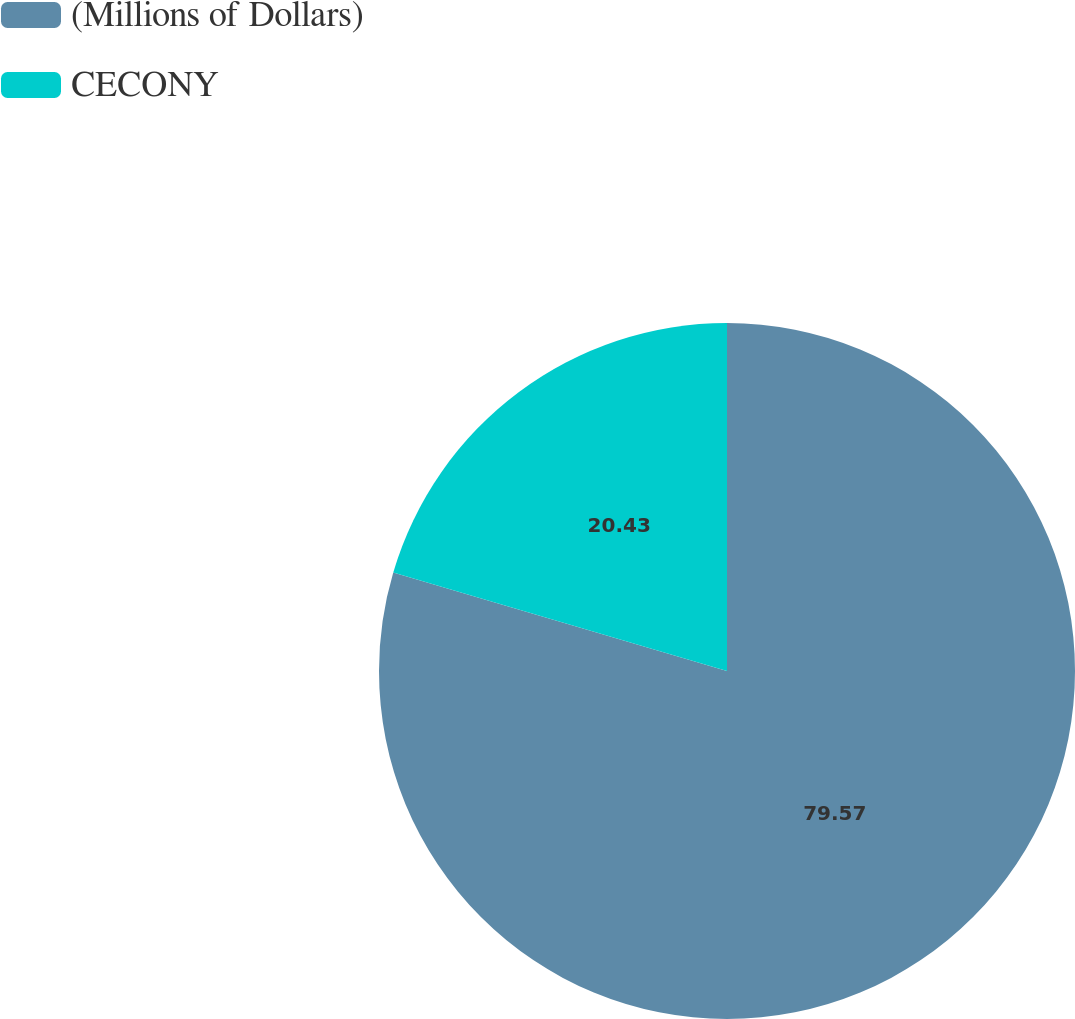Convert chart. <chart><loc_0><loc_0><loc_500><loc_500><pie_chart><fcel>(Millions of Dollars)<fcel>CECONY<nl><fcel>79.57%<fcel>20.43%<nl></chart> 